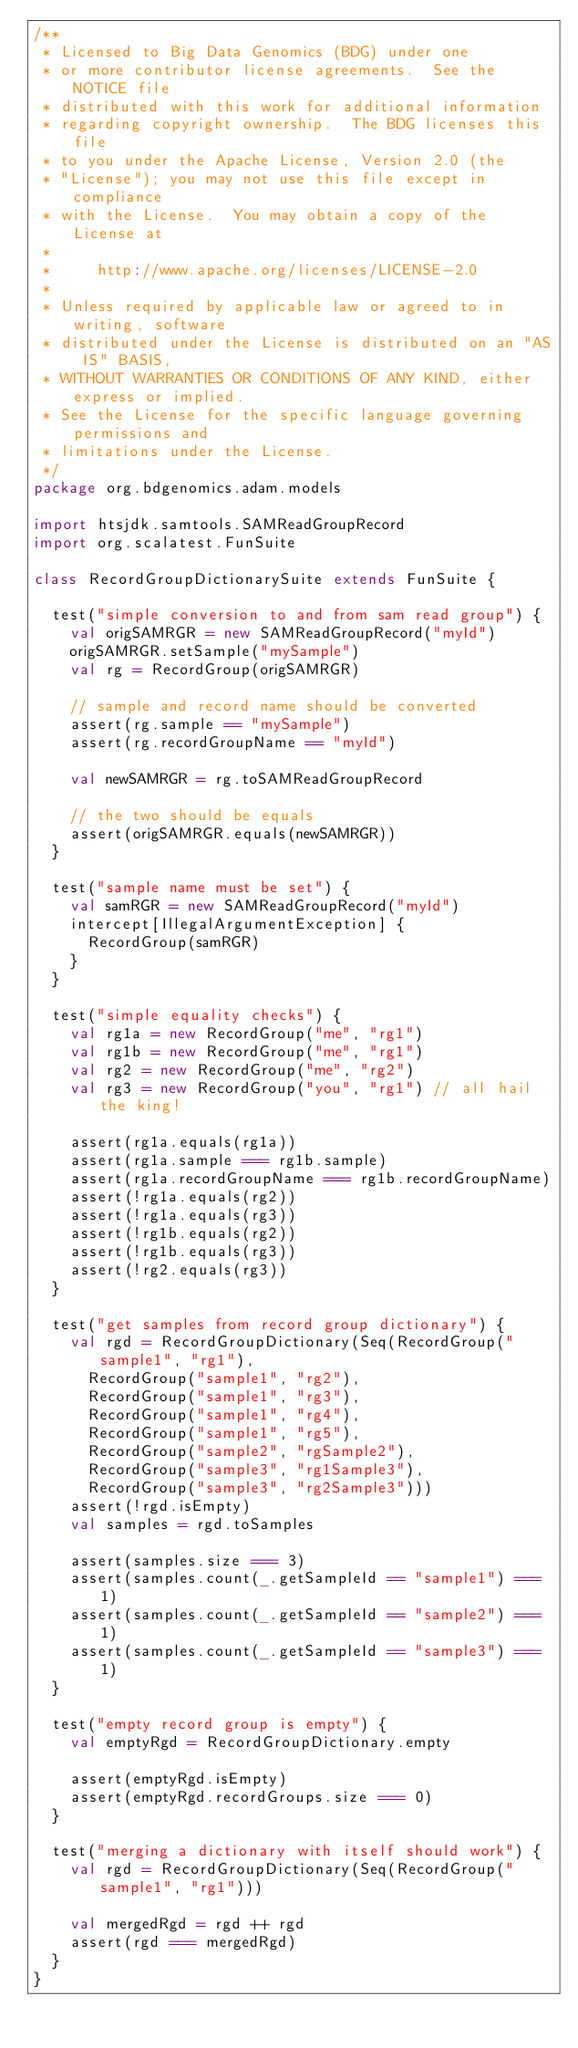Convert code to text. <code><loc_0><loc_0><loc_500><loc_500><_Scala_>/**
 * Licensed to Big Data Genomics (BDG) under one
 * or more contributor license agreements.  See the NOTICE file
 * distributed with this work for additional information
 * regarding copyright ownership.  The BDG licenses this file
 * to you under the Apache License, Version 2.0 (the
 * "License"); you may not use this file except in compliance
 * with the License.  You may obtain a copy of the License at
 *
 *     http://www.apache.org/licenses/LICENSE-2.0
 *
 * Unless required by applicable law or agreed to in writing, software
 * distributed under the License is distributed on an "AS IS" BASIS,
 * WITHOUT WARRANTIES OR CONDITIONS OF ANY KIND, either express or implied.
 * See the License for the specific language governing permissions and
 * limitations under the License.
 */
package org.bdgenomics.adam.models

import htsjdk.samtools.SAMReadGroupRecord
import org.scalatest.FunSuite

class RecordGroupDictionarySuite extends FunSuite {

  test("simple conversion to and from sam read group") {
    val origSAMRGR = new SAMReadGroupRecord("myId")
    origSAMRGR.setSample("mySample")
    val rg = RecordGroup(origSAMRGR)

    // sample and record name should be converted
    assert(rg.sample == "mySample")
    assert(rg.recordGroupName == "myId")

    val newSAMRGR = rg.toSAMReadGroupRecord

    // the two should be equals
    assert(origSAMRGR.equals(newSAMRGR))
  }

  test("sample name must be set") {
    val samRGR = new SAMReadGroupRecord("myId")
    intercept[IllegalArgumentException] {
      RecordGroup(samRGR)
    }
  }

  test("simple equality checks") {
    val rg1a = new RecordGroup("me", "rg1")
    val rg1b = new RecordGroup("me", "rg1")
    val rg2 = new RecordGroup("me", "rg2")
    val rg3 = new RecordGroup("you", "rg1") // all hail the king!

    assert(rg1a.equals(rg1a))
    assert(rg1a.sample === rg1b.sample)
    assert(rg1a.recordGroupName === rg1b.recordGroupName)
    assert(!rg1a.equals(rg2))
    assert(!rg1a.equals(rg3))
    assert(!rg1b.equals(rg2))
    assert(!rg1b.equals(rg3))
    assert(!rg2.equals(rg3))
  }

  test("get samples from record group dictionary") {
    val rgd = RecordGroupDictionary(Seq(RecordGroup("sample1", "rg1"),
      RecordGroup("sample1", "rg2"),
      RecordGroup("sample1", "rg3"),
      RecordGroup("sample1", "rg4"),
      RecordGroup("sample1", "rg5"),
      RecordGroup("sample2", "rgSample2"),
      RecordGroup("sample3", "rg1Sample3"),
      RecordGroup("sample3", "rg2Sample3")))
    assert(!rgd.isEmpty)
    val samples = rgd.toSamples

    assert(samples.size === 3)
    assert(samples.count(_.getSampleId == "sample1") === 1)
    assert(samples.count(_.getSampleId == "sample2") === 1)
    assert(samples.count(_.getSampleId == "sample3") === 1)
  }

  test("empty record group is empty") {
    val emptyRgd = RecordGroupDictionary.empty

    assert(emptyRgd.isEmpty)
    assert(emptyRgd.recordGroups.size === 0)
  }

  test("merging a dictionary with itself should work") {
    val rgd = RecordGroupDictionary(Seq(RecordGroup("sample1", "rg1")))

    val mergedRgd = rgd ++ rgd
    assert(rgd === mergedRgd)
  }
}
</code> 